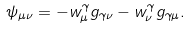<formula> <loc_0><loc_0><loc_500><loc_500>\psi _ { \mu \nu } = - w _ { \mu } ^ { \gamma } g _ { \gamma \nu } - w _ { \nu } ^ { \gamma } g _ { \gamma \mu } .</formula> 